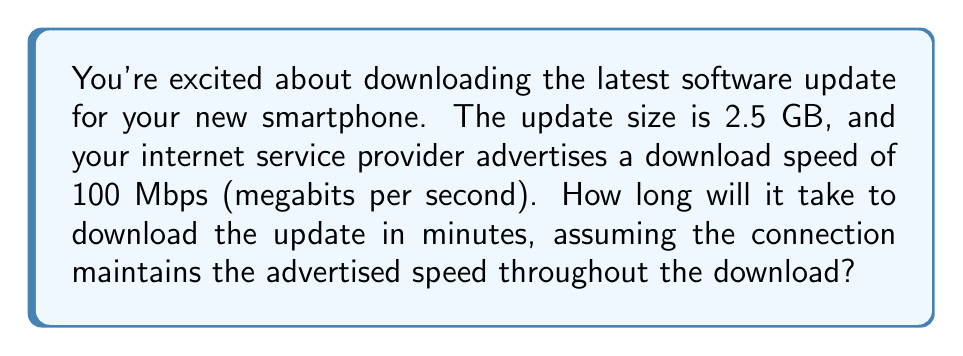Can you answer this question? To solve this problem, we need to follow these steps:

1. Convert the file size from GB to bits:
   $2.5 \text{ GB} = 2.5 \times 1024 \text{ MB} = 2.5 \times 1024 \times 8 \text{ Mb}$
   $= 20,480 \text{ Mb}$

2. Calculate the time needed to download:
   $$\text{Time (seconds)} = \frac{\text{File size (Mb)}}{\text{Download speed (Mbps)}}$$
   $$= \frac{20,480 \text{ Mb}}{100 \text{ Mbps}} = 204.8 \text{ seconds}$$

3. Convert the time from seconds to minutes:
   $$\text{Time (minutes)} = \frac{204.8 \text{ seconds}}{60 \text{ seconds/minute}} = 3.41333... \text{ minutes}$$

4. Round to two decimal places:
   $3.41 \text{ minutes}$
Answer: It will take approximately 3.41 minutes to download the 2.5 GB update at a constant speed of 100 Mbps. 